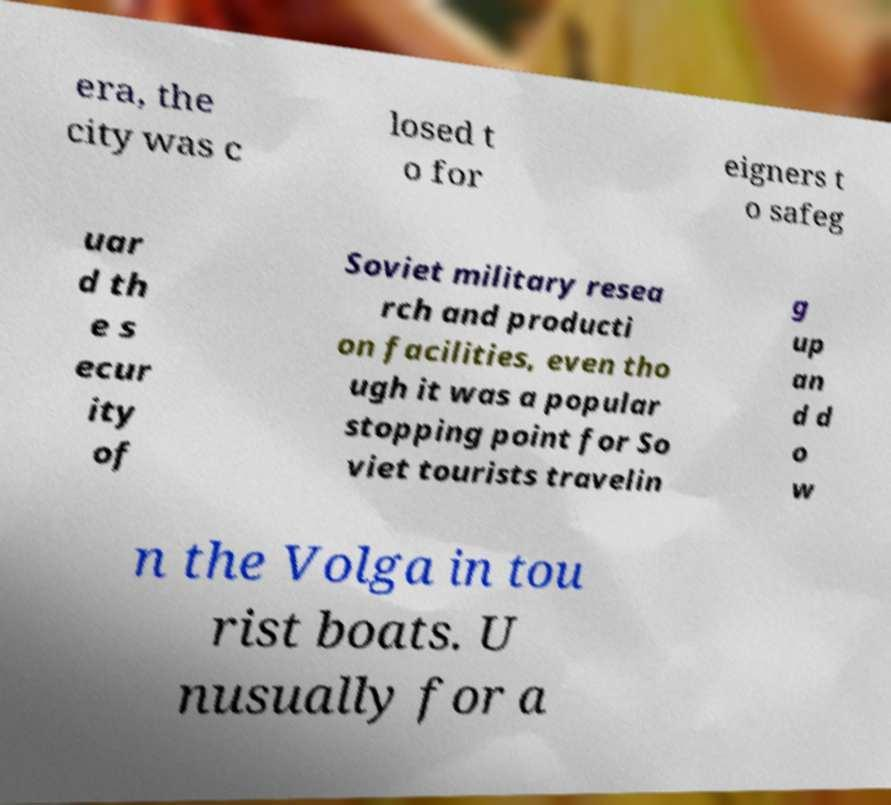There's text embedded in this image that I need extracted. Can you transcribe it verbatim? era, the city was c losed t o for eigners t o safeg uar d th e s ecur ity of Soviet military resea rch and producti on facilities, even tho ugh it was a popular stopping point for So viet tourists travelin g up an d d o w n the Volga in tou rist boats. U nusually for a 